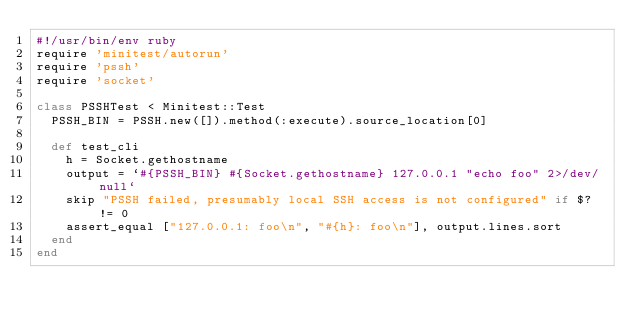Convert code to text. <code><loc_0><loc_0><loc_500><loc_500><_Ruby_>#!/usr/bin/env ruby
require 'minitest/autorun'
require 'pssh'
require 'socket'

class PSSHTest < Minitest::Test
  PSSH_BIN = PSSH.new([]).method(:execute).source_location[0]

  def test_cli
    h = Socket.gethostname
    output = `#{PSSH_BIN} #{Socket.gethostname} 127.0.0.1 "echo foo" 2>/dev/null`
    skip "PSSH failed, presumably local SSH access is not configured" if $? != 0
    assert_equal ["127.0.0.1: foo\n", "#{h}: foo\n"], output.lines.sort
  end
end
</code> 